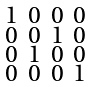<formula> <loc_0><loc_0><loc_500><loc_500>\begin{smallmatrix} 1 & 0 & 0 & 0 \\ 0 & 0 & 1 & 0 \\ 0 & 1 & 0 & 0 \\ 0 & 0 & 0 & 1 \end{smallmatrix}</formula> 